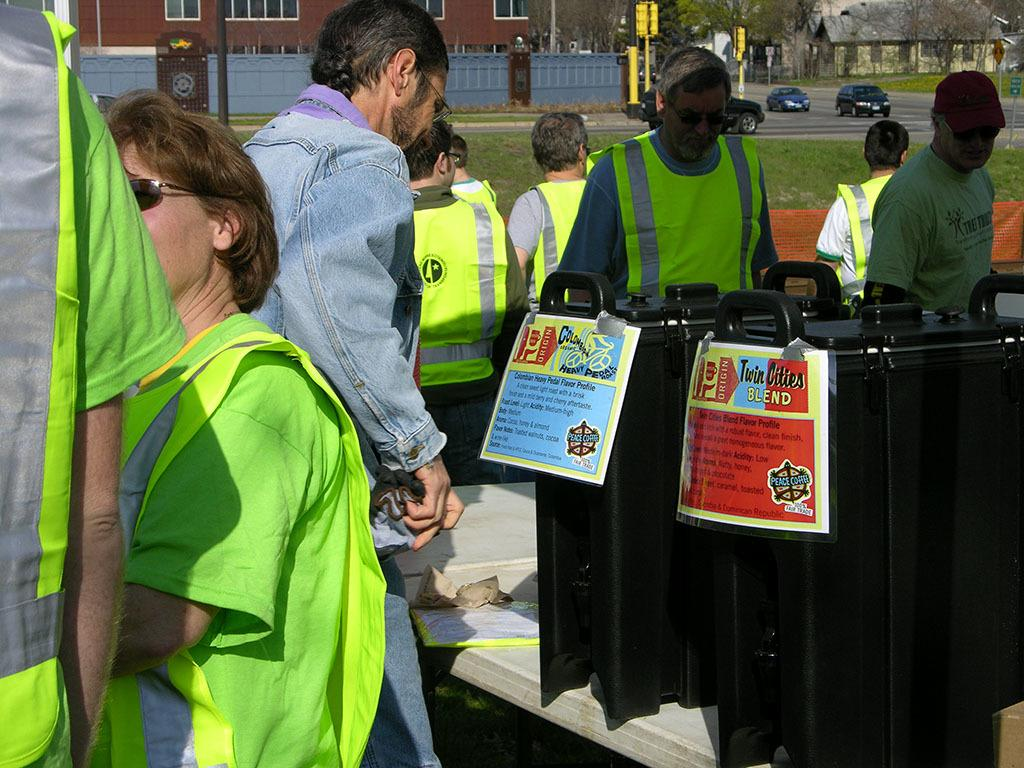<image>
Write a terse but informative summary of the picture. Entrance turnstiles for something called the Twin Cities Blend. 